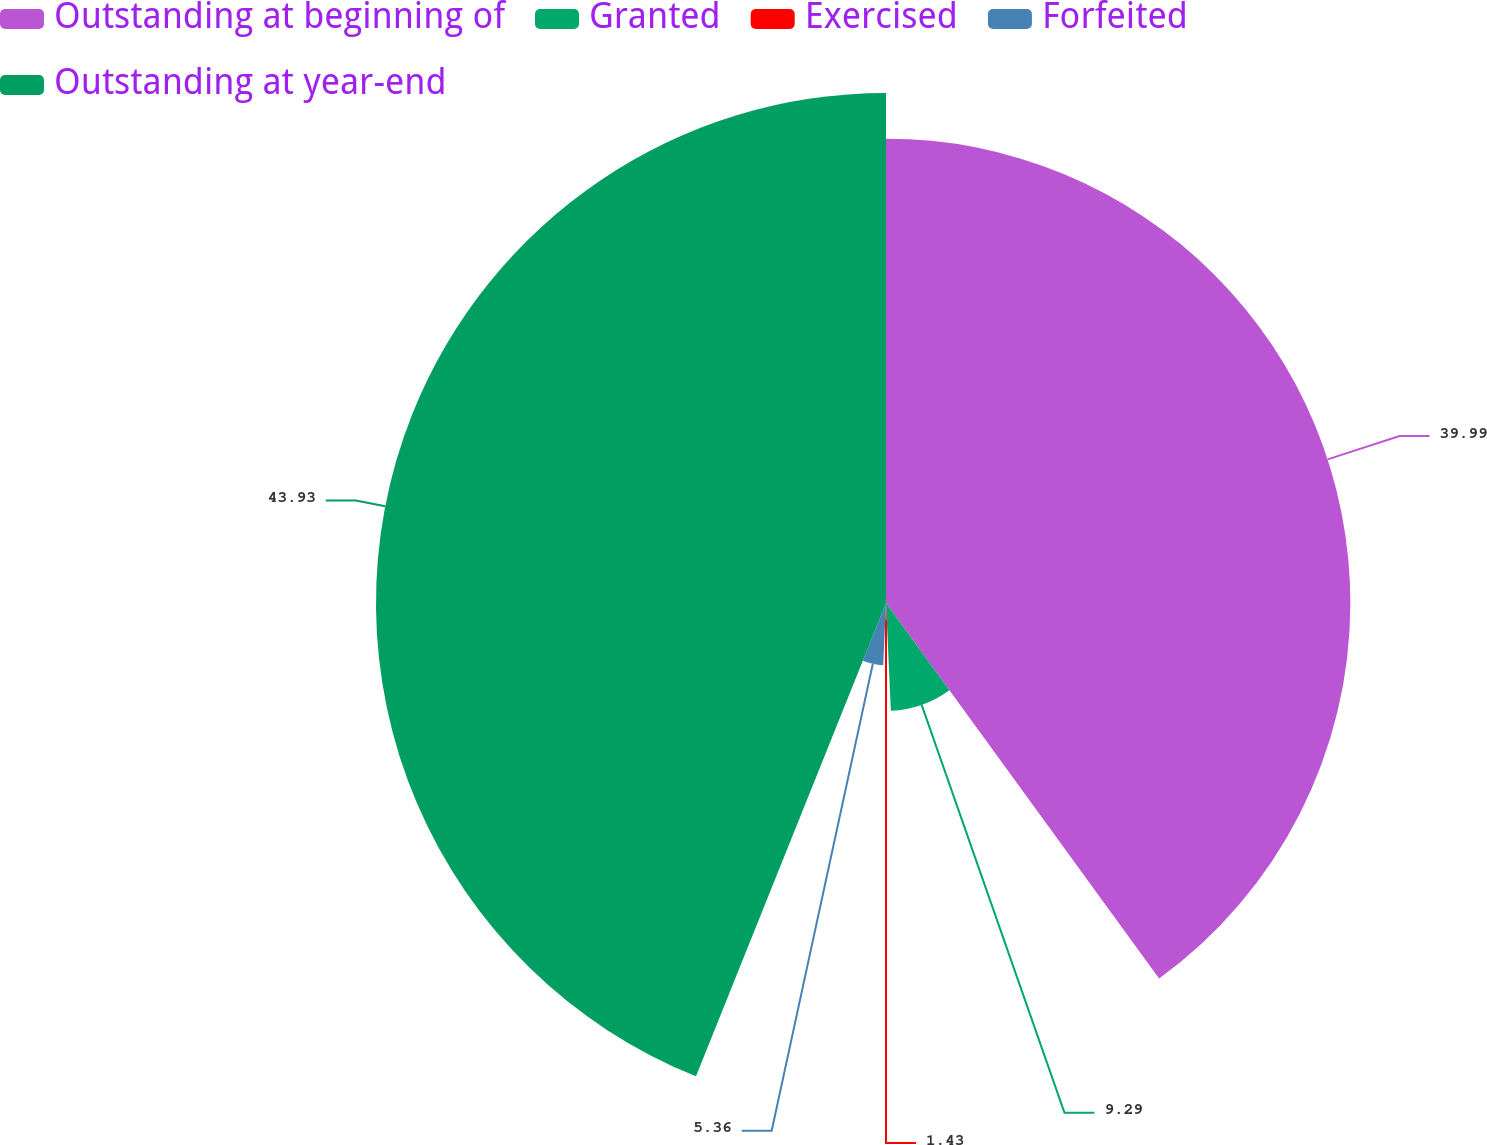Convert chart to OTSL. <chart><loc_0><loc_0><loc_500><loc_500><pie_chart><fcel>Outstanding at beginning of<fcel>Granted<fcel>Exercised<fcel>Forfeited<fcel>Outstanding at year-end<nl><fcel>39.99%<fcel>9.29%<fcel>1.43%<fcel>5.36%<fcel>43.92%<nl></chart> 